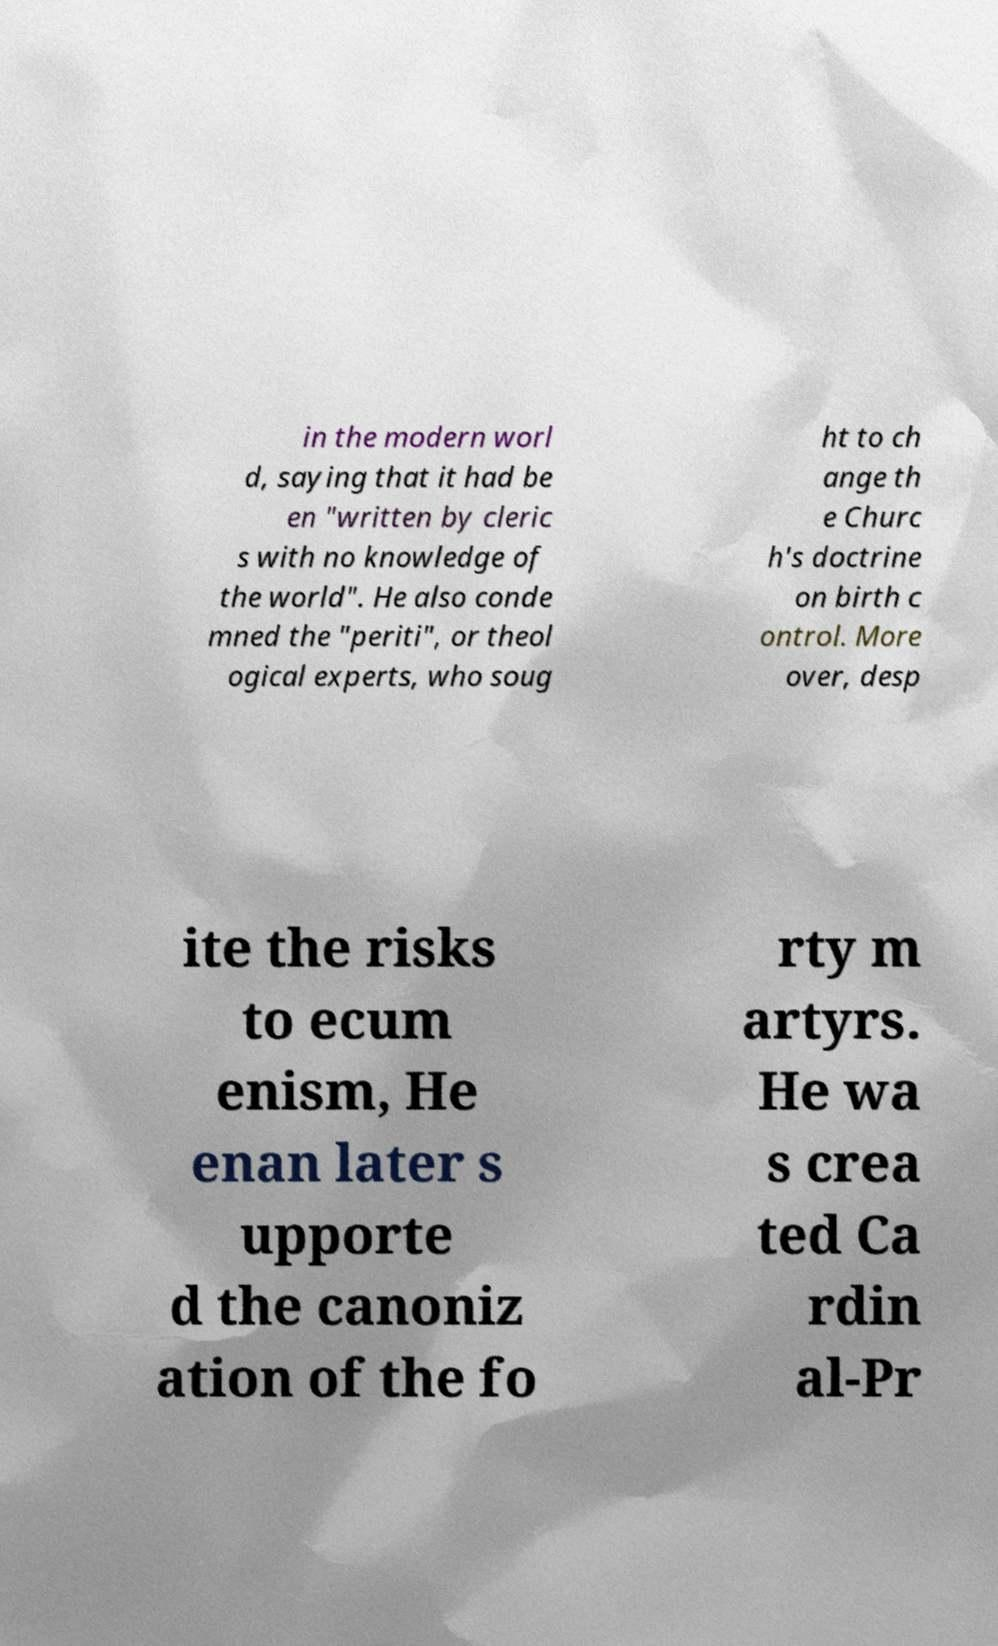For documentation purposes, I need the text within this image transcribed. Could you provide that? in the modern worl d, saying that it had be en "written by cleric s with no knowledge of the world". He also conde mned the "periti", or theol ogical experts, who soug ht to ch ange th e Churc h's doctrine on birth c ontrol. More over, desp ite the risks to ecum enism, He enan later s upporte d the canoniz ation of the fo rty m artyrs. He wa s crea ted Ca rdin al-Pr 